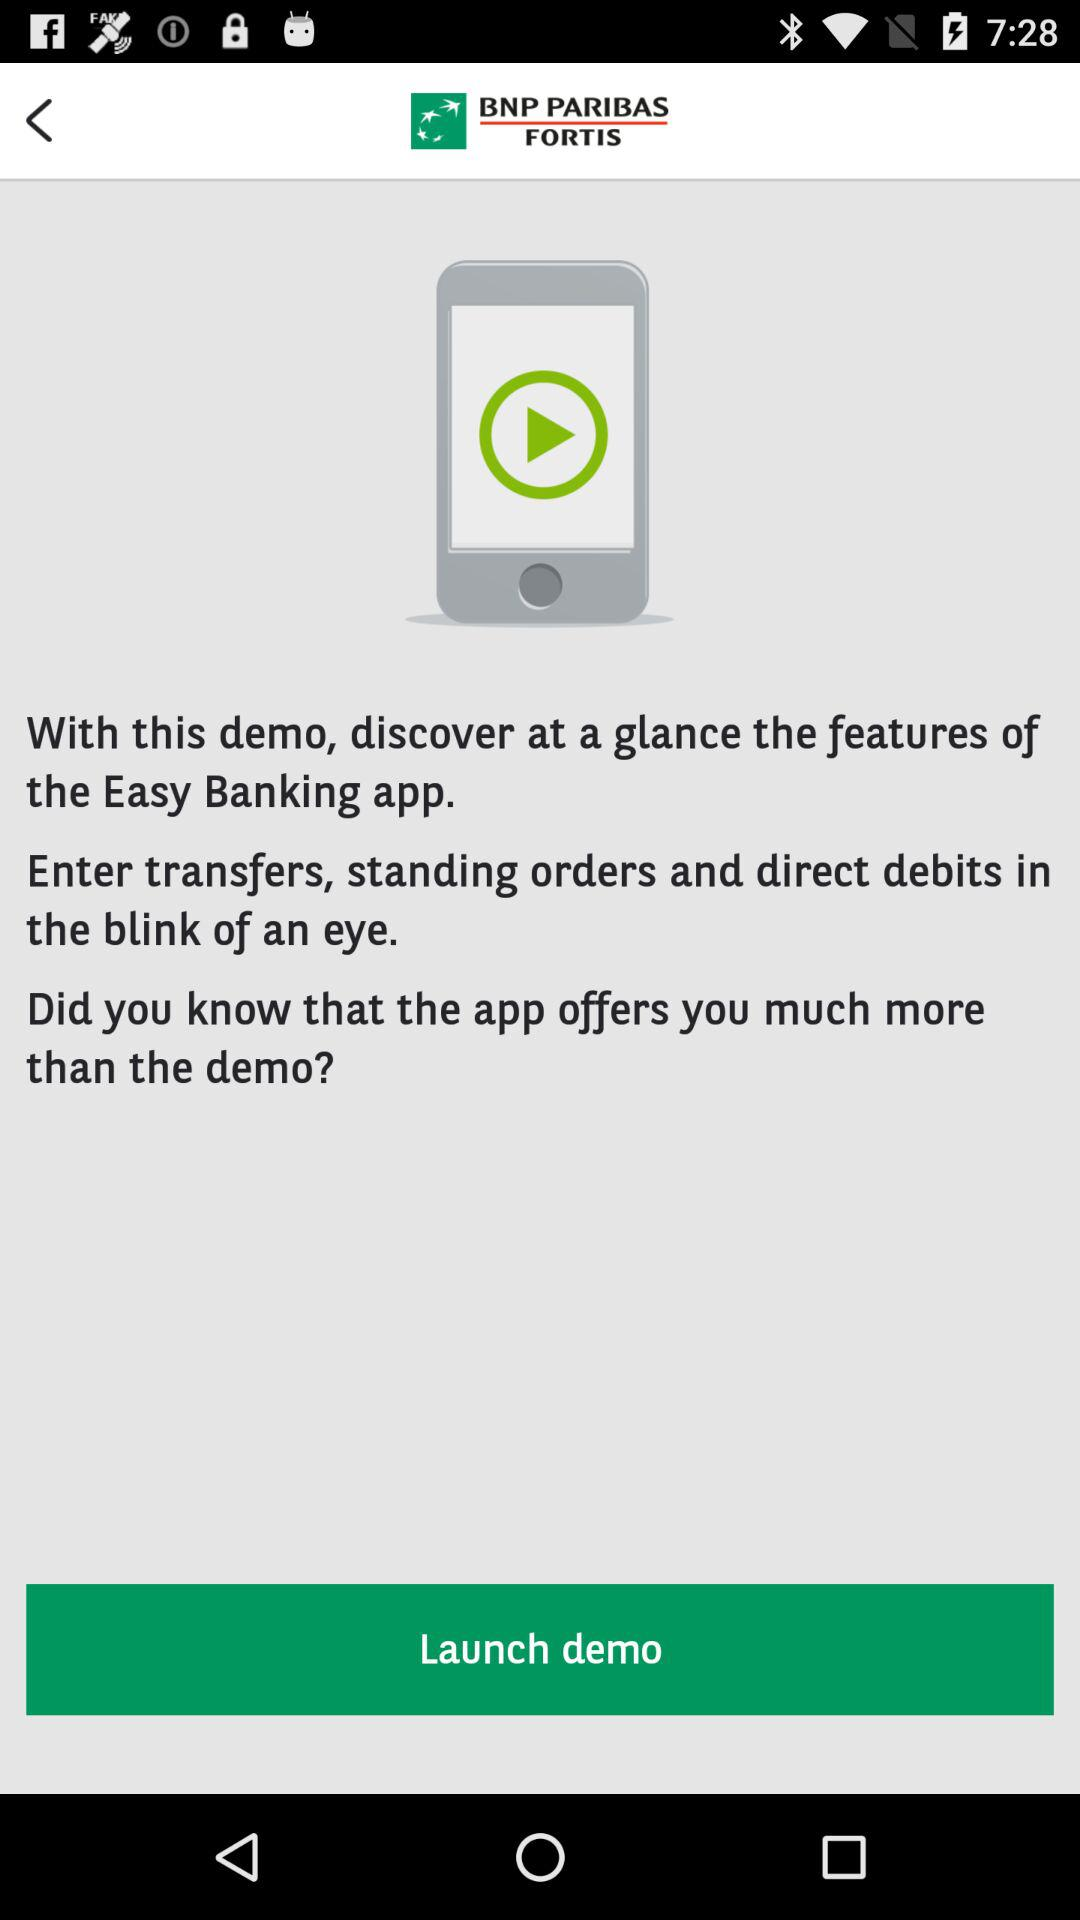What is the name of the application?
Answer the question using a single word or phrase. The name of the application is "BNP PARIBAS FORTIS" 